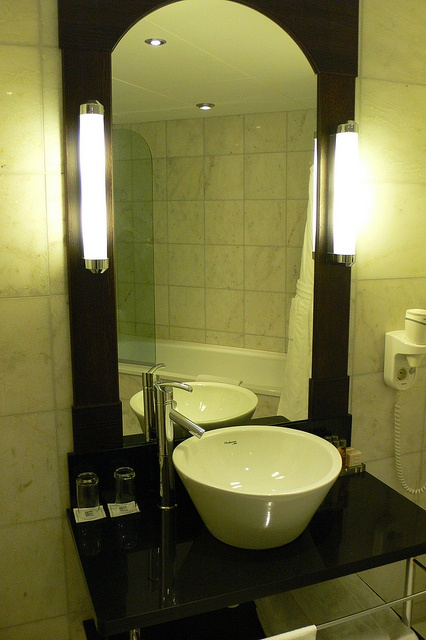Describe the objects in this image and their specific colors. I can see sink in olive, khaki, darkgreen, and black tones, cup in olive and black tones, and cup in olive and black tones in this image. 